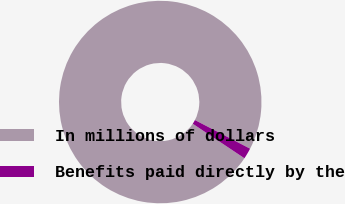Convert chart to OTSL. <chart><loc_0><loc_0><loc_500><loc_500><pie_chart><fcel>In millions of dollars<fcel>Benefits paid directly by the<nl><fcel>98.25%<fcel>1.75%<nl></chart> 